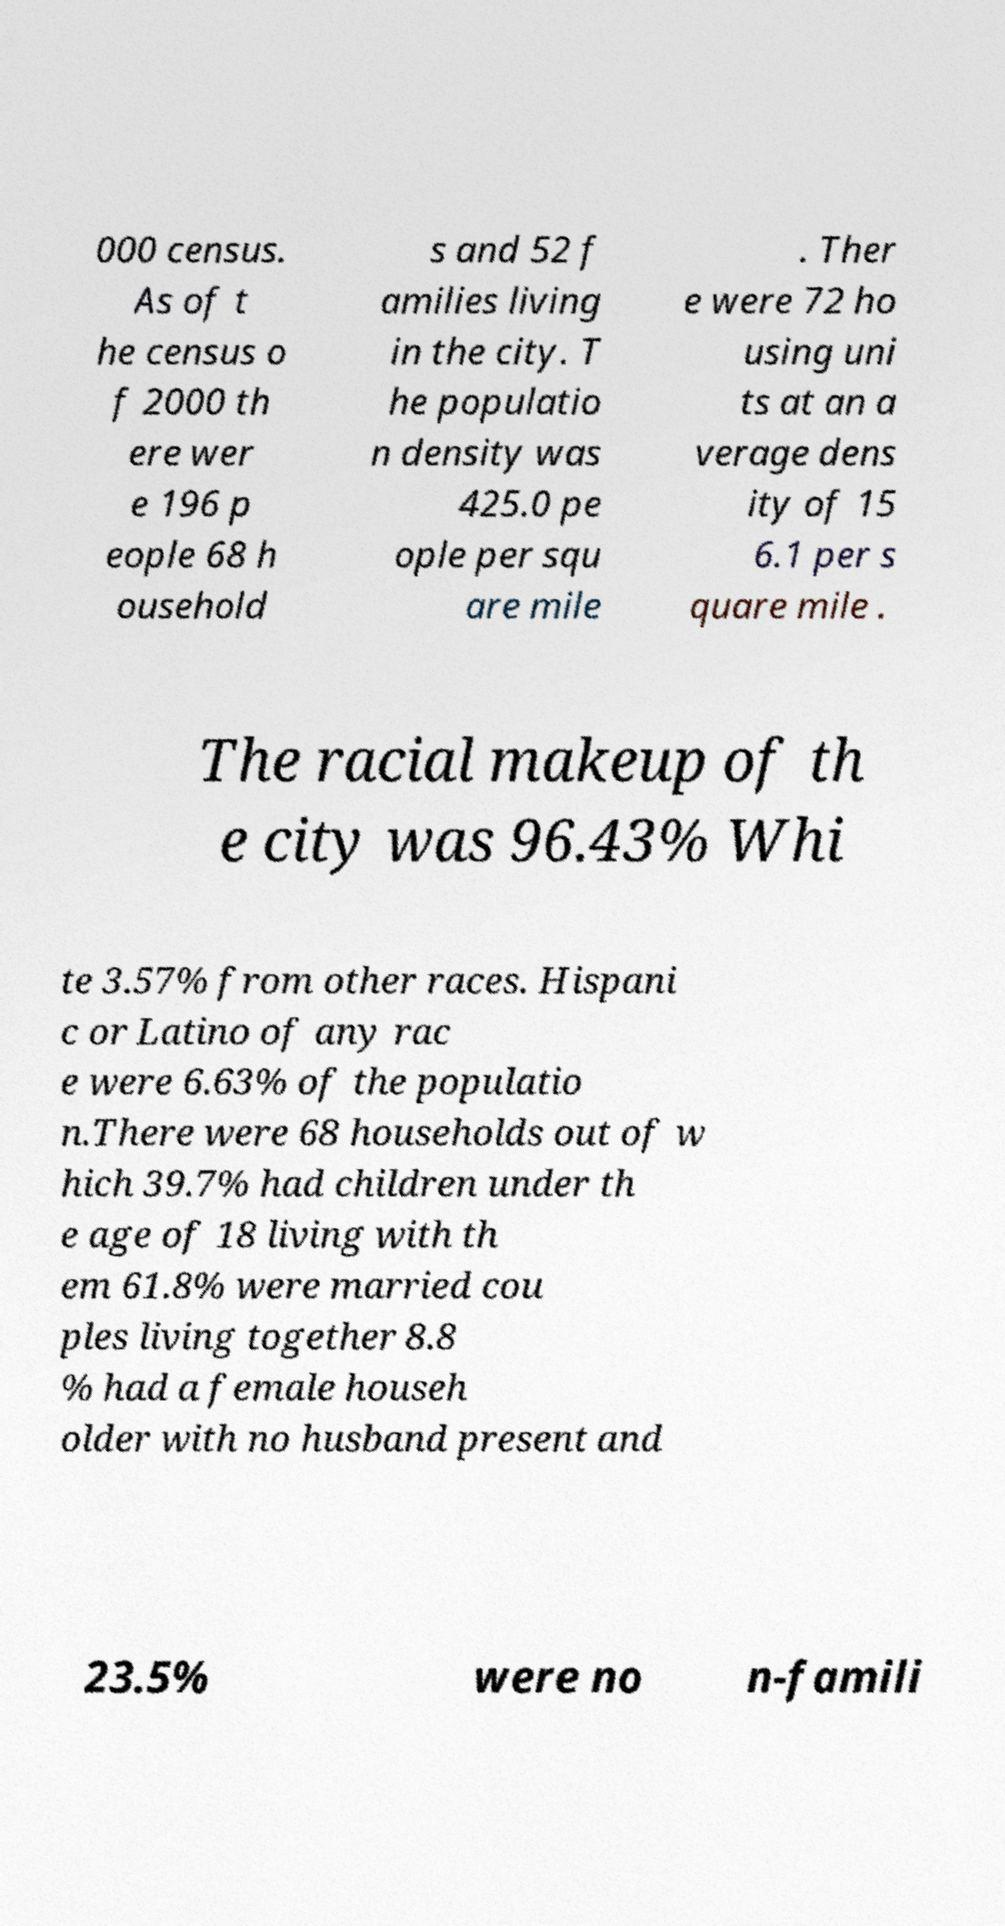Can you accurately transcribe the text from the provided image for me? 000 census. As of t he census o f 2000 th ere wer e 196 p eople 68 h ousehold s and 52 f amilies living in the city. T he populatio n density was 425.0 pe ople per squ are mile . Ther e were 72 ho using uni ts at an a verage dens ity of 15 6.1 per s quare mile . The racial makeup of th e city was 96.43% Whi te 3.57% from other races. Hispani c or Latino of any rac e were 6.63% of the populatio n.There were 68 households out of w hich 39.7% had children under th e age of 18 living with th em 61.8% were married cou ples living together 8.8 % had a female househ older with no husband present and 23.5% were no n-famili 